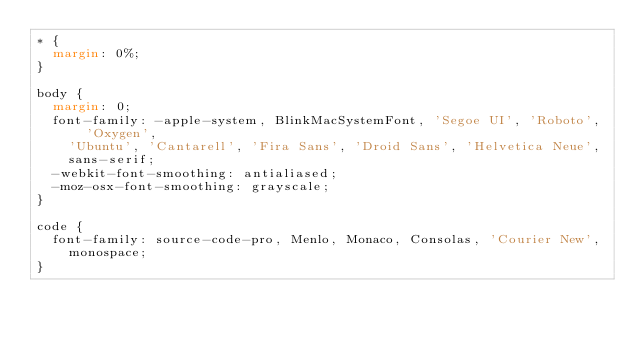<code> <loc_0><loc_0><loc_500><loc_500><_CSS_>* {
  margin: 0%;
}

body {
  margin: 0;
  font-family: -apple-system, BlinkMacSystemFont, 'Segoe UI', 'Roboto', 'Oxygen',
    'Ubuntu', 'Cantarell', 'Fira Sans', 'Droid Sans', 'Helvetica Neue',
    sans-serif;
  -webkit-font-smoothing: antialiased;
  -moz-osx-font-smoothing: grayscale;
}

code {
  font-family: source-code-pro, Menlo, Monaco, Consolas, 'Courier New',
    monospace;
}
</code> 